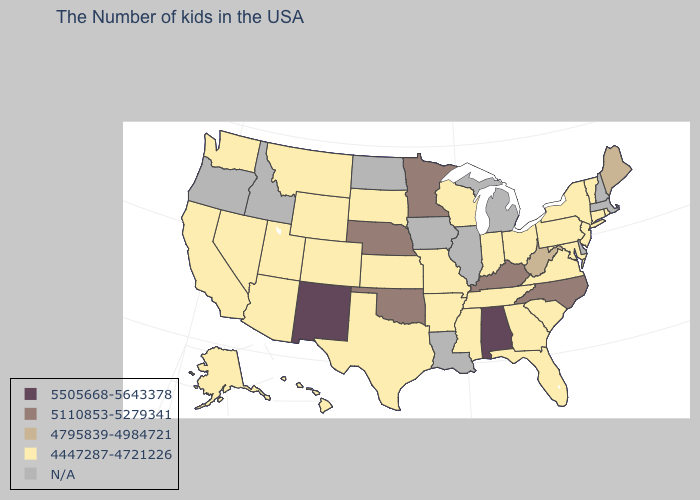What is the highest value in states that border Texas?
Short answer required. 5505668-5643378. What is the value of Oregon?
Quick response, please. N/A. Which states have the lowest value in the USA?
Short answer required. Rhode Island, Vermont, Connecticut, New York, New Jersey, Maryland, Pennsylvania, Virginia, South Carolina, Ohio, Florida, Georgia, Indiana, Tennessee, Wisconsin, Mississippi, Missouri, Arkansas, Kansas, Texas, South Dakota, Wyoming, Colorado, Utah, Montana, Arizona, Nevada, California, Washington, Alaska, Hawaii. What is the value of Alaska?
Concise answer only. 4447287-4721226. Does the map have missing data?
Concise answer only. Yes. What is the value of Maryland?
Quick response, please. 4447287-4721226. How many symbols are there in the legend?
Write a very short answer. 5. What is the highest value in the West ?
Be succinct. 5505668-5643378. Does the map have missing data?
Short answer required. Yes. What is the value of California?
Be succinct. 4447287-4721226. Does New Jersey have the highest value in the Northeast?
Short answer required. No. What is the value of New Mexico?
Concise answer only. 5505668-5643378. Name the states that have a value in the range 5110853-5279341?
Answer briefly. North Carolina, Kentucky, Minnesota, Nebraska, Oklahoma. Which states have the highest value in the USA?
Concise answer only. Alabama, New Mexico. 